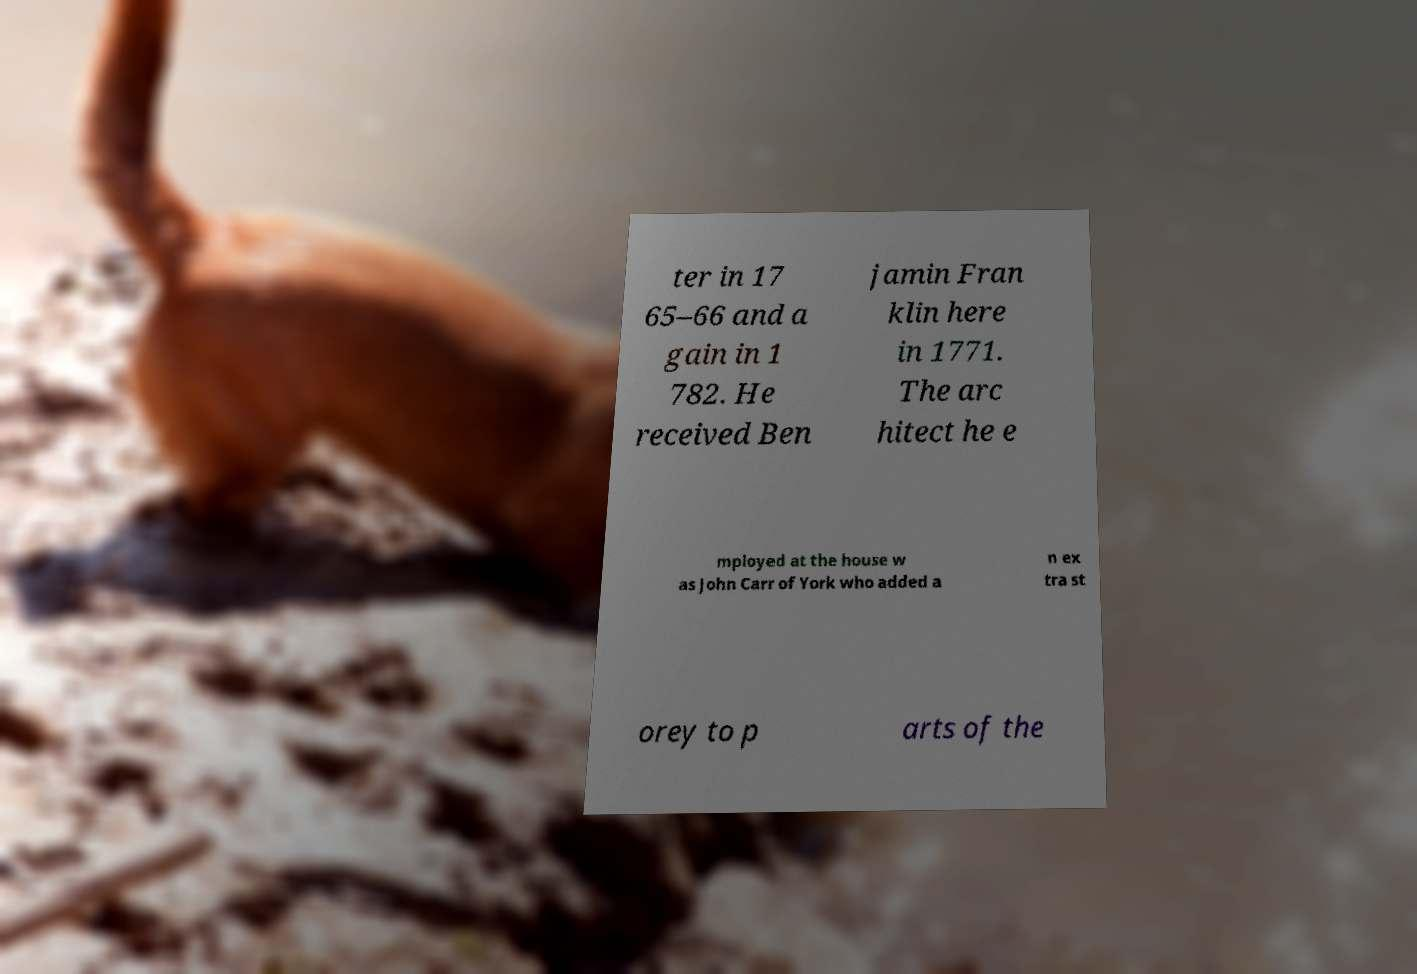For documentation purposes, I need the text within this image transcribed. Could you provide that? ter in 17 65–66 and a gain in 1 782. He received Ben jamin Fran klin here in 1771. The arc hitect he e mployed at the house w as John Carr of York who added a n ex tra st orey to p arts of the 